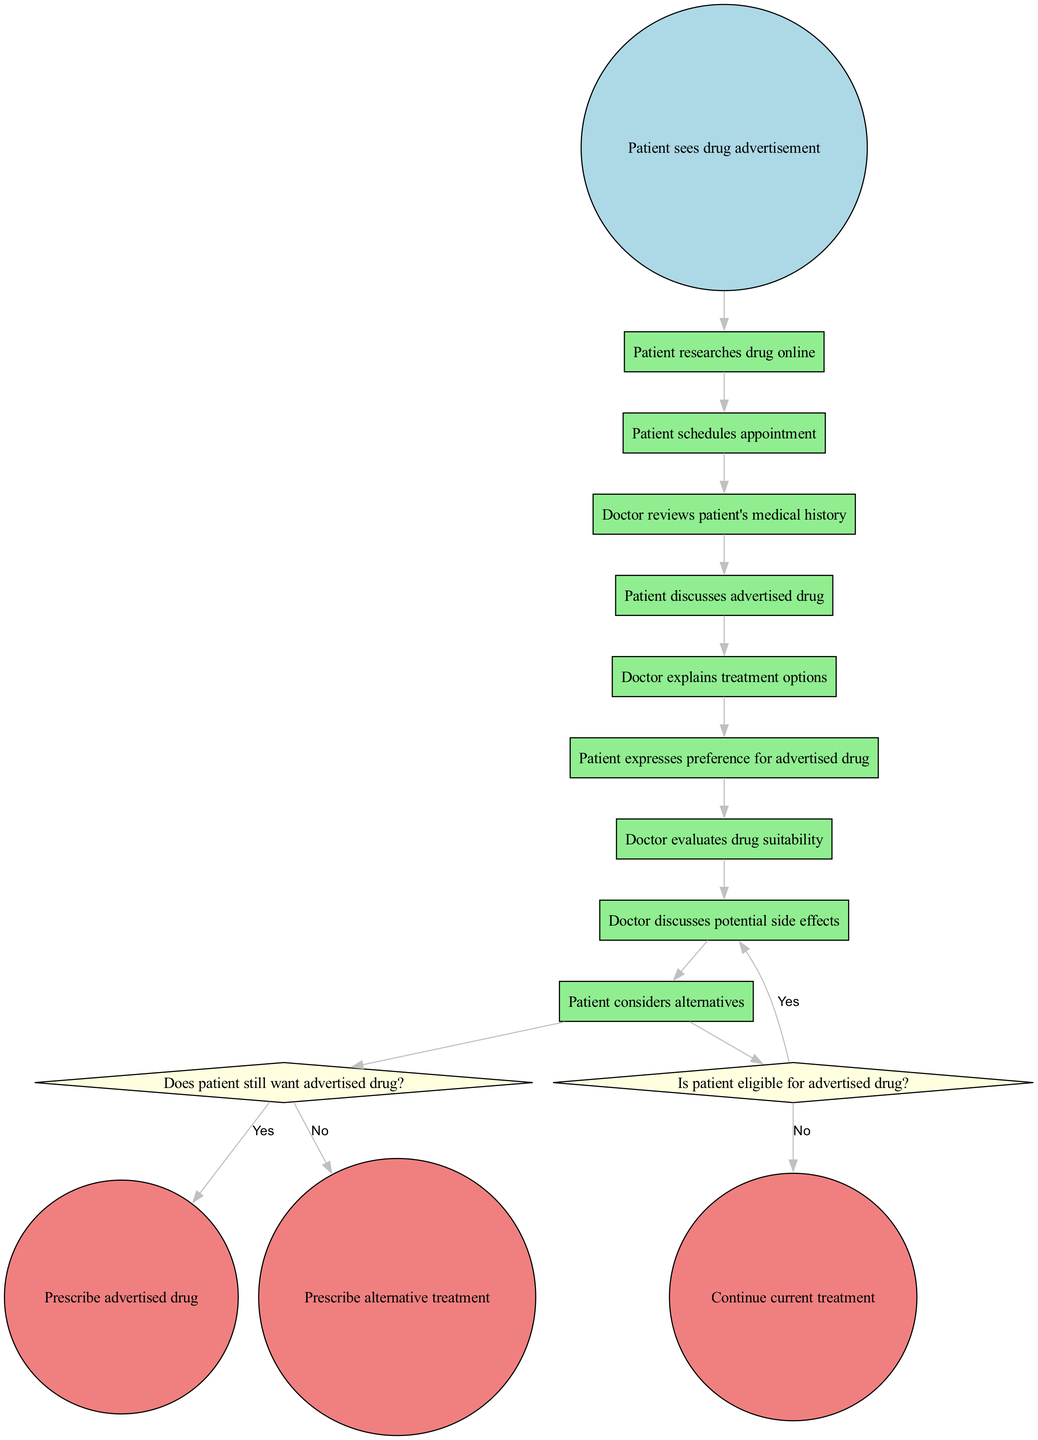What is the initial node in the diagram? The initial node is labeled "Patient sees drug advertisement," as this is where the interaction begins according to the diagram.
Answer: Patient sees drug advertisement How many activities are present in the diagram? The diagram lists eight distinct activities before moving to decisions, so the total number of activities is counted as eight.
Answer: 8 What decision comes after the patient discusses the advertised drug? After the patient discusses the advertised drug, the next step in the diagram is the decision labeled "Is patient eligible for advertised drug?" indicating it is a crucial point in the decision-making process.
Answer: Is patient eligible for advertised drug? What happens if the patient is not eligible for the advertised drug? If the patient is not eligible for the advertised drug, the flow leads to the final node labeled "Prescribe alternative treatment," indicating that the prescribed action will switch to alternatives.
Answer: Prescribe alternative treatment How many final nodes are depicted in the diagram? The diagram shows three final nodes, representing the potential outcomes of the treatment decision-making process, namely: "Prescribe advertised drug," "Prescribe alternative treatment," and "Continue current treatment."
Answer: 3 What is the next step after the patient expresses a preference for the advertised drug? After the patient expresses preference for the advertised drug, the following decision is to evaluate if the patient is eligible, indicated as "Is patient eligible for advertised drug?" confirming that a vital eligibility check must be conducted.
Answer: Is patient eligible for advertised drug? What occurs if the patient disagrees with the doctor's recommendation? If the patient disagrees with the doctor's recommendation, the flow leads to "Continue current treatment," highlighting that consultation can lead to maintaining the current treatment approach instead of switching to the drug discussed.
Answer: Continue current treatment After the patient's consideration of alternatives, what is the next decision node? Following the patient's consideration of alternatives, the next decision node is labeled "Does patient still want advertised drug?" signifying a critical juncture in evaluating the patient's ongoing desire for the advertised drug.
Answer: Does patient still want advertised drug? 